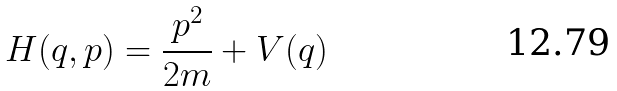<formula> <loc_0><loc_0><loc_500><loc_500>H ( q , p ) = \frac { p ^ { 2 } } { 2 m } + V ( q )</formula> 